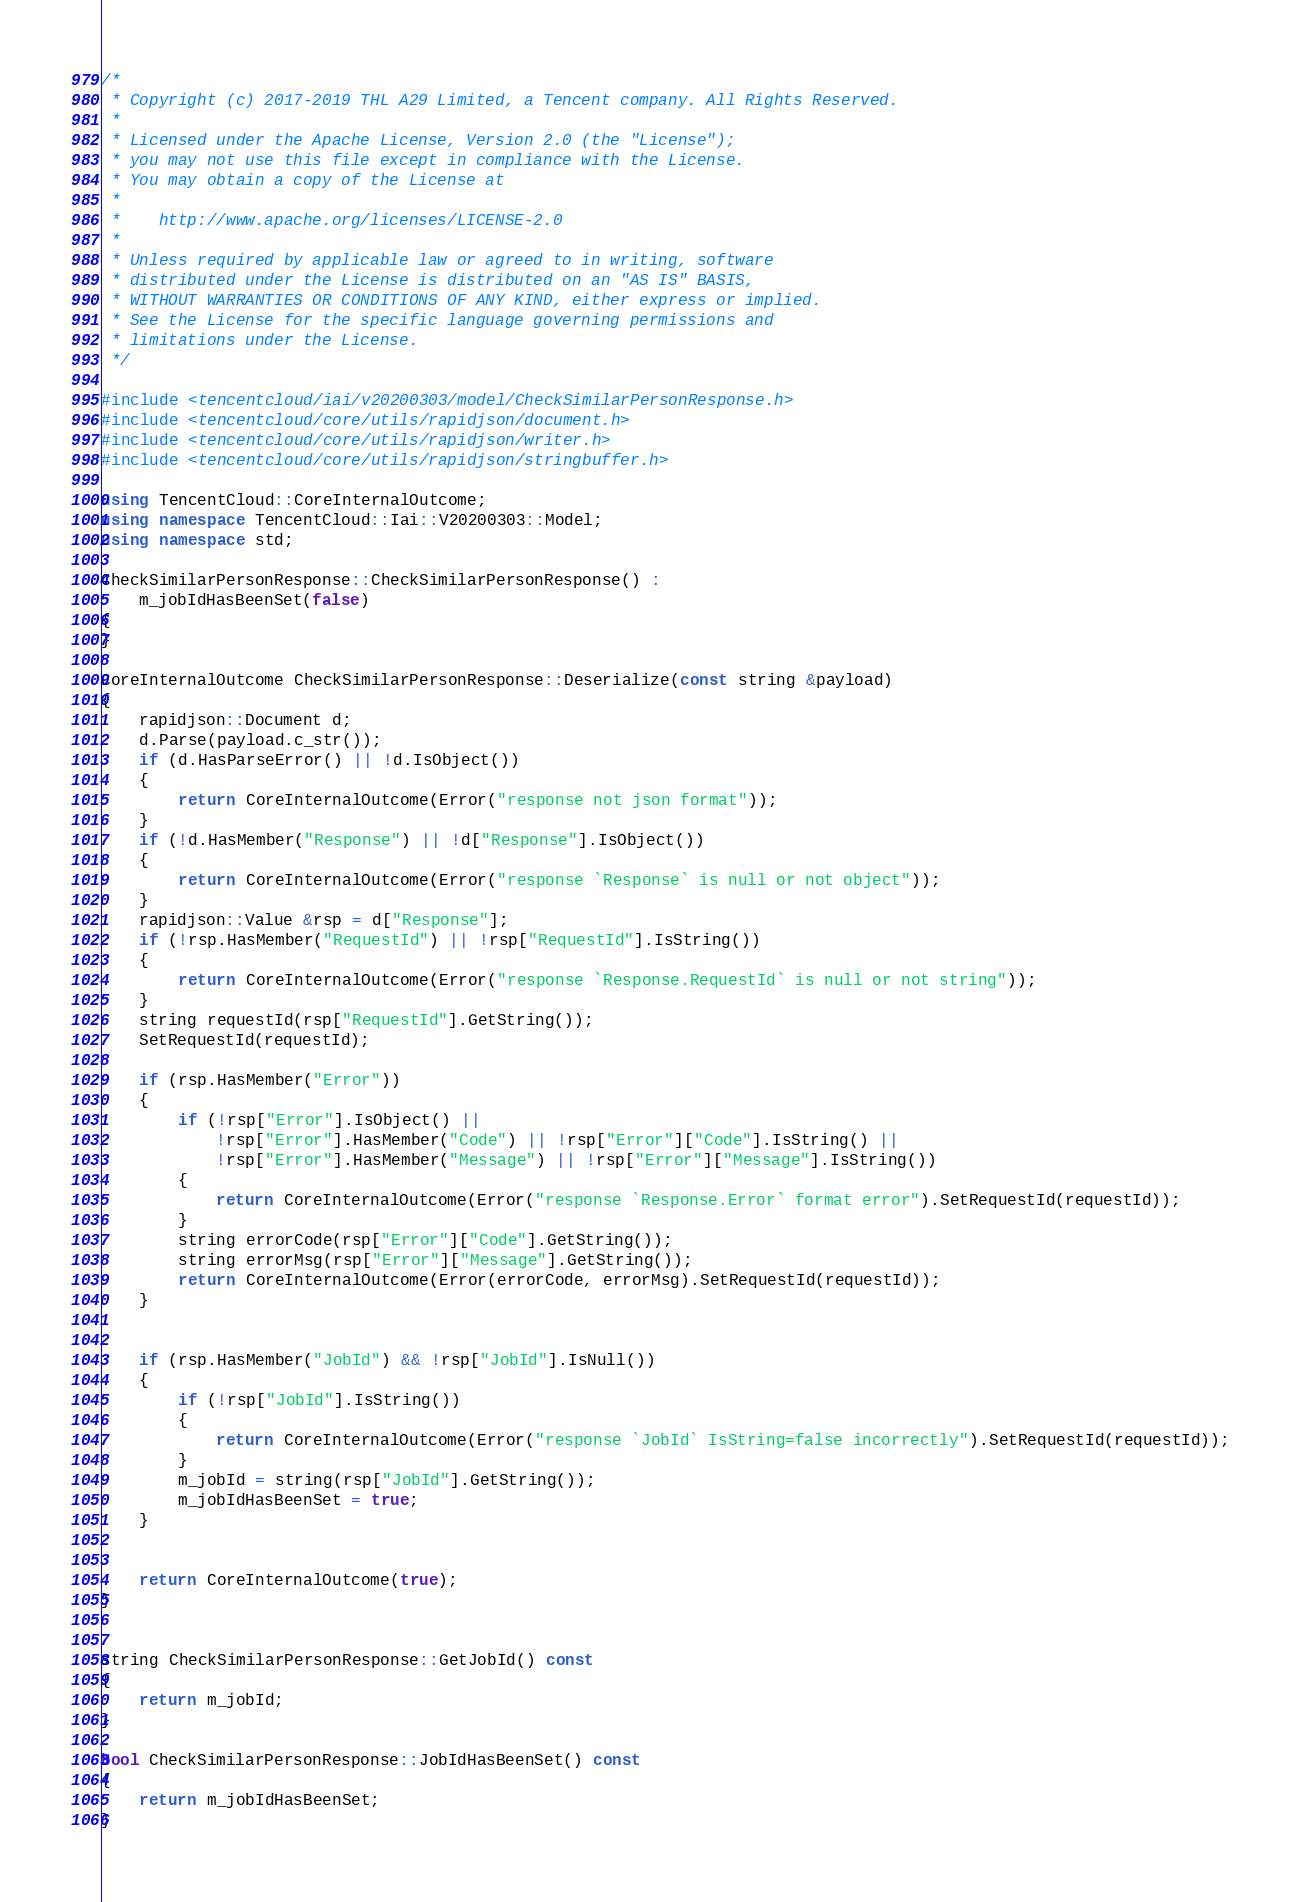Convert code to text. <code><loc_0><loc_0><loc_500><loc_500><_C++_>/*
 * Copyright (c) 2017-2019 THL A29 Limited, a Tencent company. All Rights Reserved.
 *
 * Licensed under the Apache License, Version 2.0 (the "License");
 * you may not use this file except in compliance with the License.
 * You may obtain a copy of the License at
 *
 *    http://www.apache.org/licenses/LICENSE-2.0
 *
 * Unless required by applicable law or agreed to in writing, software
 * distributed under the License is distributed on an "AS IS" BASIS,
 * WITHOUT WARRANTIES OR CONDITIONS OF ANY KIND, either express or implied.
 * See the License for the specific language governing permissions and
 * limitations under the License.
 */

#include <tencentcloud/iai/v20200303/model/CheckSimilarPersonResponse.h>
#include <tencentcloud/core/utils/rapidjson/document.h>
#include <tencentcloud/core/utils/rapidjson/writer.h>
#include <tencentcloud/core/utils/rapidjson/stringbuffer.h>

using TencentCloud::CoreInternalOutcome;
using namespace TencentCloud::Iai::V20200303::Model;
using namespace std;

CheckSimilarPersonResponse::CheckSimilarPersonResponse() :
    m_jobIdHasBeenSet(false)
{
}

CoreInternalOutcome CheckSimilarPersonResponse::Deserialize(const string &payload)
{
    rapidjson::Document d;
    d.Parse(payload.c_str());
    if (d.HasParseError() || !d.IsObject())
    {
        return CoreInternalOutcome(Error("response not json format"));
    }
    if (!d.HasMember("Response") || !d["Response"].IsObject())
    {
        return CoreInternalOutcome(Error("response `Response` is null or not object"));
    }
    rapidjson::Value &rsp = d["Response"];
    if (!rsp.HasMember("RequestId") || !rsp["RequestId"].IsString())
    {
        return CoreInternalOutcome(Error("response `Response.RequestId` is null or not string"));
    }
    string requestId(rsp["RequestId"].GetString());
    SetRequestId(requestId);

    if (rsp.HasMember("Error"))
    {
        if (!rsp["Error"].IsObject() ||
            !rsp["Error"].HasMember("Code") || !rsp["Error"]["Code"].IsString() ||
            !rsp["Error"].HasMember("Message") || !rsp["Error"]["Message"].IsString())
        {
            return CoreInternalOutcome(Error("response `Response.Error` format error").SetRequestId(requestId));
        }
        string errorCode(rsp["Error"]["Code"].GetString());
        string errorMsg(rsp["Error"]["Message"].GetString());
        return CoreInternalOutcome(Error(errorCode, errorMsg).SetRequestId(requestId));
    }


    if (rsp.HasMember("JobId") && !rsp["JobId"].IsNull())
    {
        if (!rsp["JobId"].IsString())
        {
            return CoreInternalOutcome(Error("response `JobId` IsString=false incorrectly").SetRequestId(requestId));
        }
        m_jobId = string(rsp["JobId"].GetString());
        m_jobIdHasBeenSet = true;
    }


    return CoreInternalOutcome(true);
}


string CheckSimilarPersonResponse::GetJobId() const
{
    return m_jobId;
}

bool CheckSimilarPersonResponse::JobIdHasBeenSet() const
{
    return m_jobIdHasBeenSet;
}


</code> 